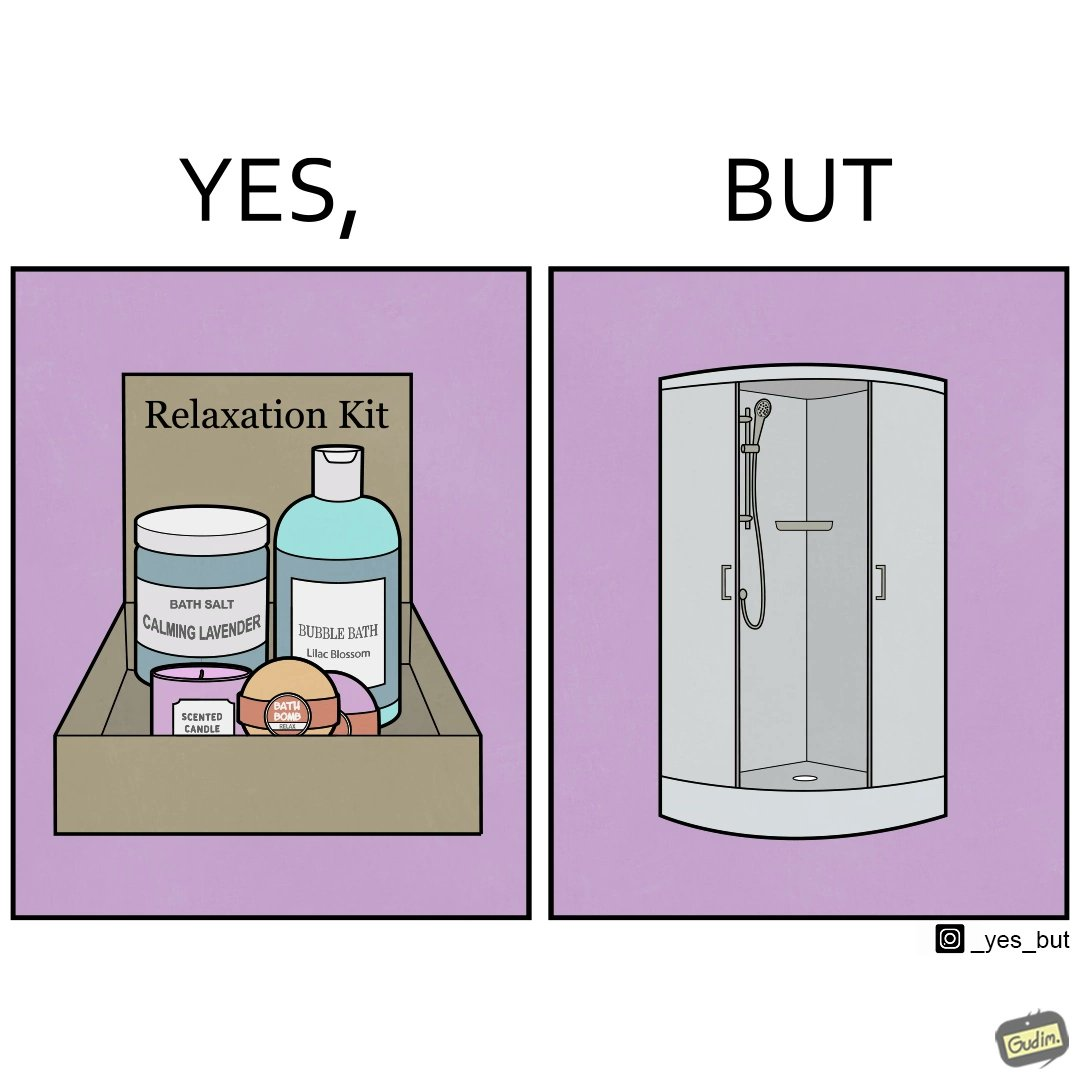Compare the left and right sides of this image. In the left part of the image: a relaxation kit, with several products intended to bring calm and peace to the person using the kit. In the right part of the image: a showering area with doors. 